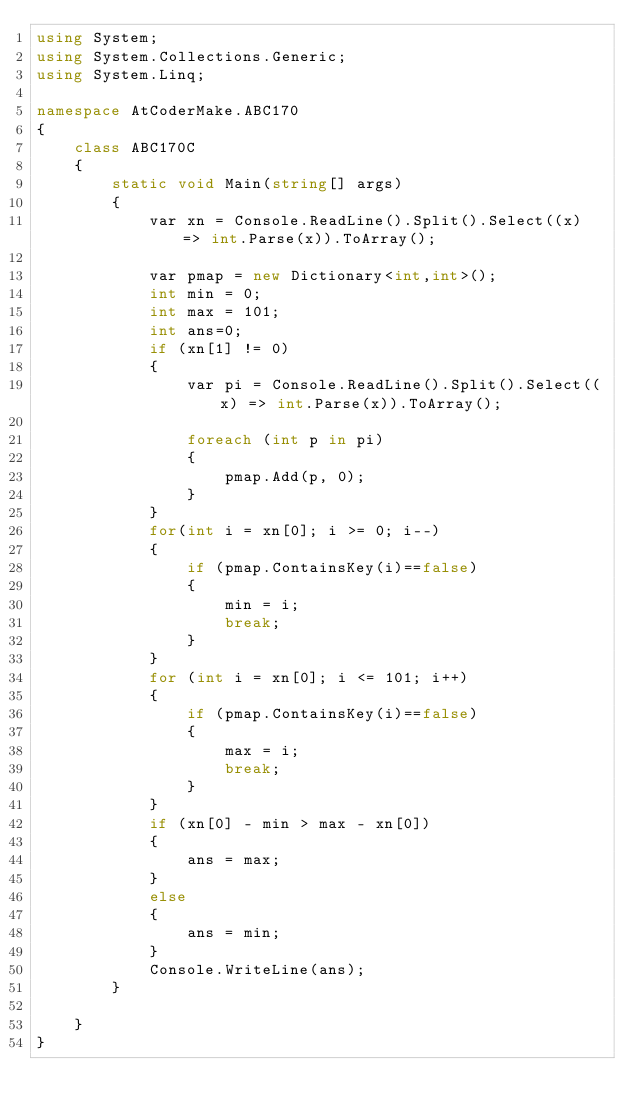<code> <loc_0><loc_0><loc_500><loc_500><_C#_>using System;
using System.Collections.Generic;
using System.Linq;

namespace AtCoderMake.ABC170
{
    class ABC170C
    {
        static void Main(string[] args)
        {
            var xn = Console.ReadLine().Split().Select((x) => int.Parse(x)).ToArray();
            
            var pmap = new Dictionary<int,int>();
            int min = 0;
            int max = 101;
            int ans=0;
            if (xn[1] != 0)
            {
                var pi = Console.ReadLine().Split().Select((x) => int.Parse(x)).ToArray();

                foreach (int p in pi)
                {
                    pmap.Add(p, 0);
                }
            }
            for(int i = xn[0]; i >= 0; i--)
            {
                if (pmap.ContainsKey(i)==false)
                {
                    min = i;
                    break;
                }
            }
            for (int i = xn[0]; i <= 101; i++)
            {
                if (pmap.ContainsKey(i)==false)
                {
                    max = i;
                    break;
                }
            }
            if (xn[0] - min > max - xn[0])
            {
                ans = max;
            }
            else
            {
                ans = min;
            }
            Console.WriteLine(ans);
        }
        
    }
}
</code> 